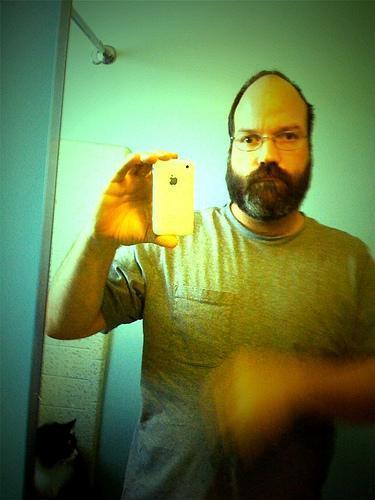How many phones the man are  holding?
Give a very brief answer. 1. 